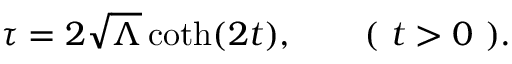Convert formula to latex. <formula><loc_0><loc_0><loc_500><loc_500>\tau = 2 \sqrt { \Lambda } \coth ( 2 t ) , \quad ( t > 0 ) .</formula> 